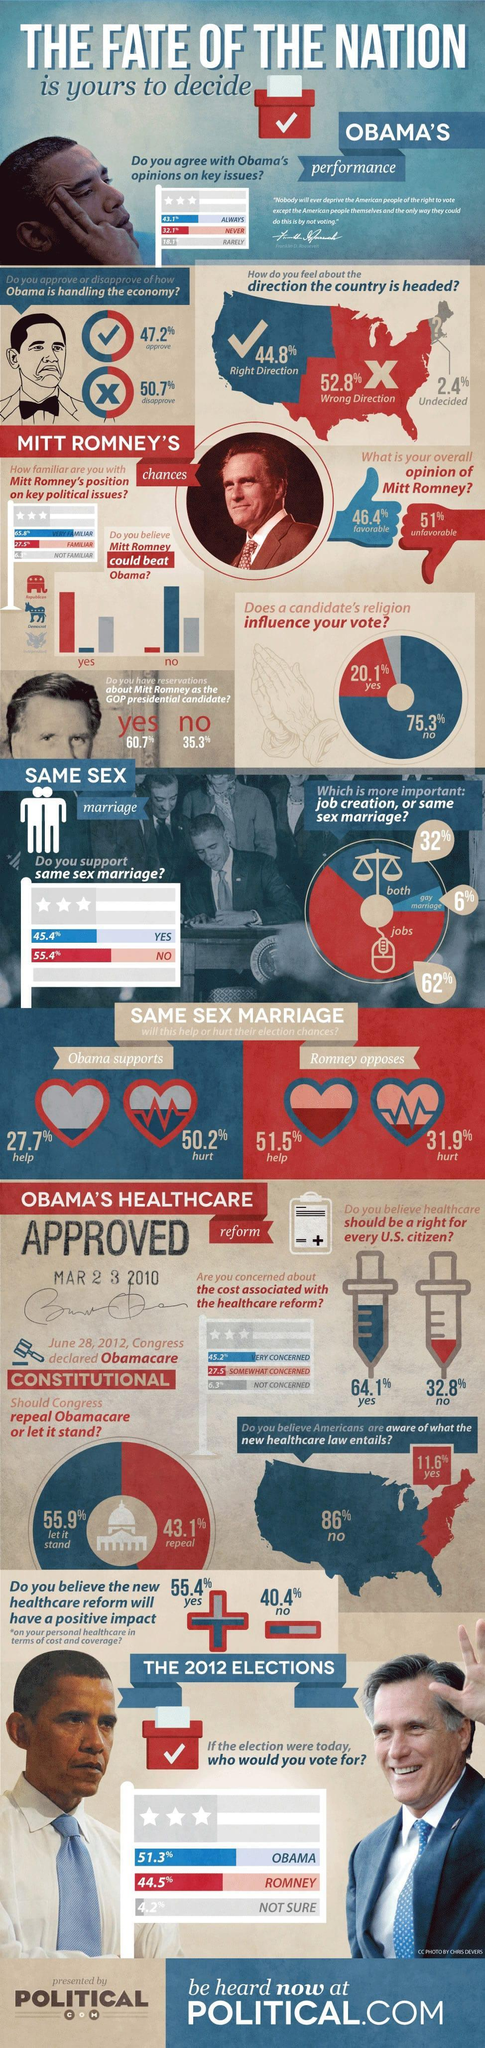What percent of Americans always agree with Obama's opinions on key issues of the nation according to the survey?
Answer the question with a short phrase. 43.1% What percent of Americans disapproves of how Obama is handling the economy as per the survey? 50.7% What percent of Americans do not support same sex marriage according to the survey? 55.4% What percent of Americans felt that job creation is more important than the same sex marriage according to the survey? 62% What percent of Americans believe that the new healthcare reform will have a positive impact according to the survey? 55.4% What percent of Americans believe that healthcare should be a right for every US citizen according to the survey? 64.1% What percent of respondents agreed that a candidate's religion will influence their vote as per the survey? 20.1% What percent of Americans has a favourable opinion about Mitt Romney according to the survey? 46.4% What percent of Americans feel that the country is headed in the right direction as per the survey? 44.8% 